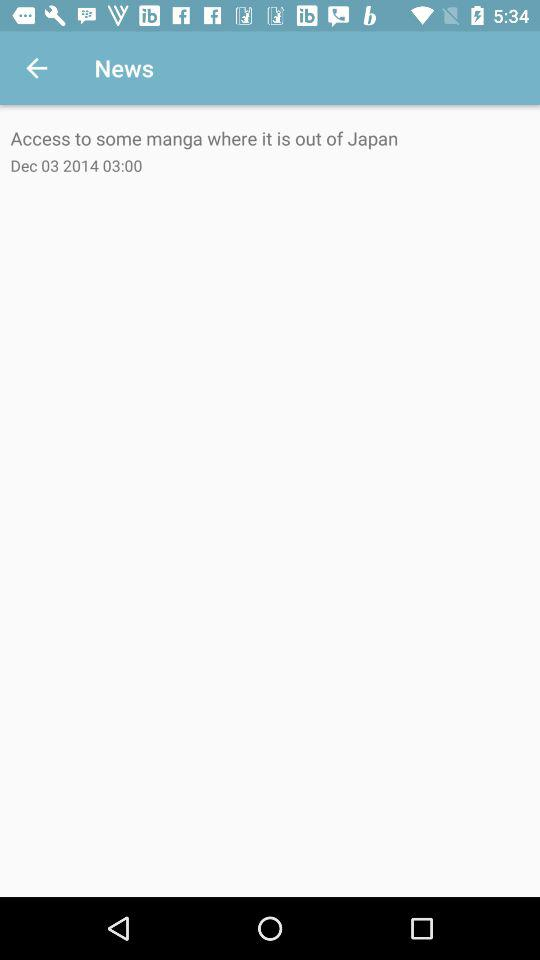What is the name of the application?
When the provided information is insufficient, respond with <no answer>. <no answer> 